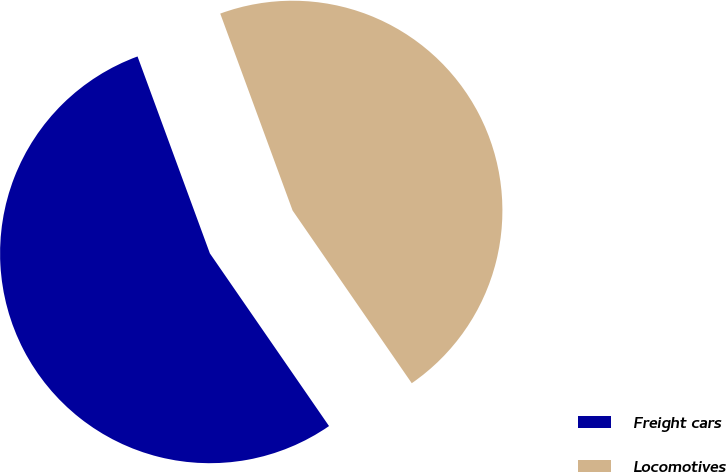Convert chart. <chart><loc_0><loc_0><loc_500><loc_500><pie_chart><fcel>Freight cars<fcel>Locomotives<nl><fcel>54.01%<fcel>45.99%<nl></chart> 